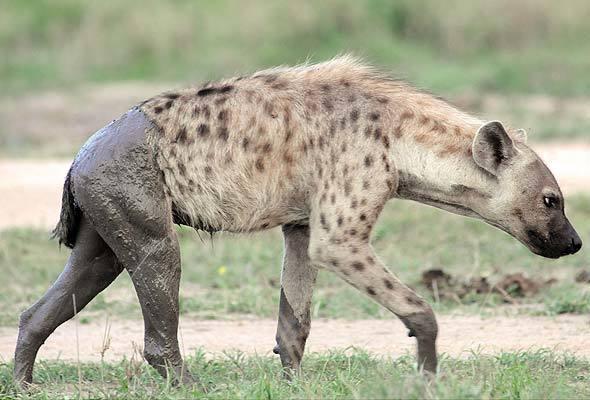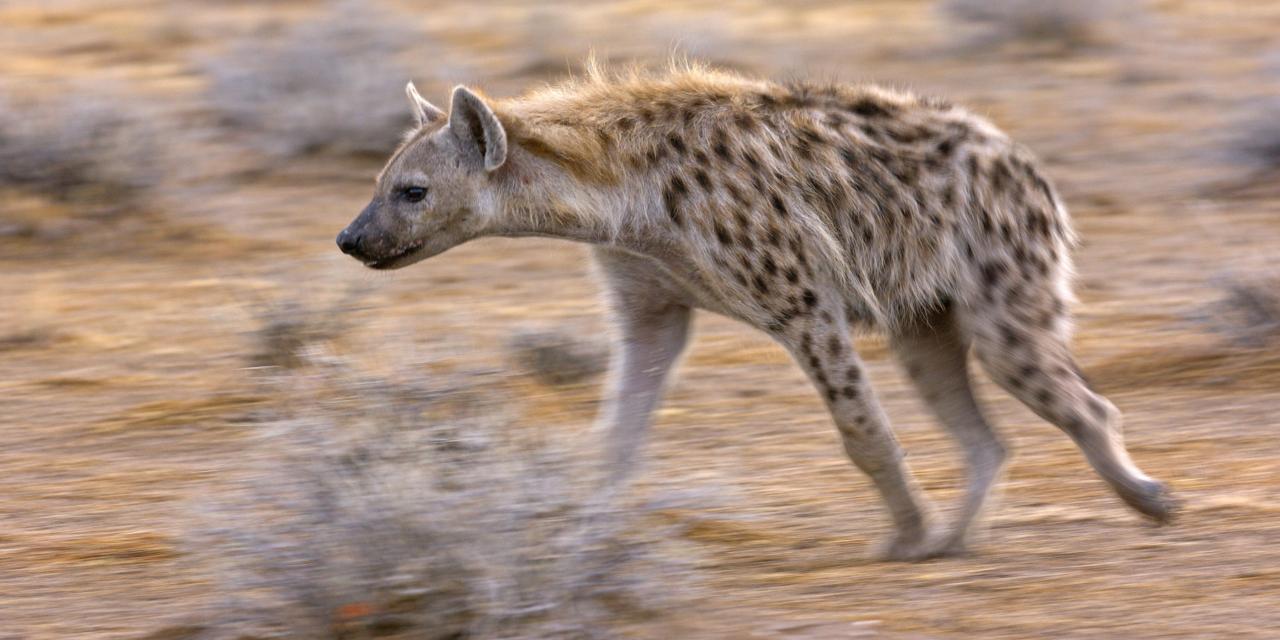The first image is the image on the left, the second image is the image on the right. Evaluate the accuracy of this statement regarding the images: "There is at least three animals total across the images.". Is it true? Answer yes or no. No. 